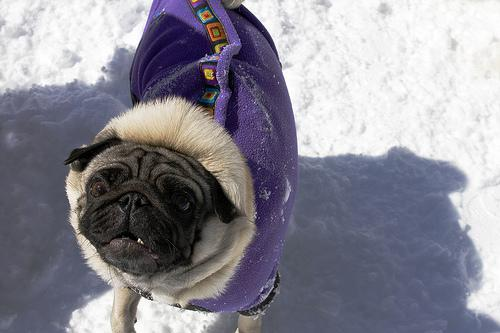Question: what color is the sweater?
Choices:
A. Purple.
B. Pink.
C. Blue.
D. Red.
Answer with the letter. Answer: A Question: what breed of dog is this?
Choices:
A. A pitbull.
B. A pug.
C. A collie.
D. A dauchsand.
Answer with the letter. Answer: B Question: what season is it?
Choices:
A. Spring.
B. Summer.
C. Winter.
D. Fall.
Answer with the letter. Answer: C 